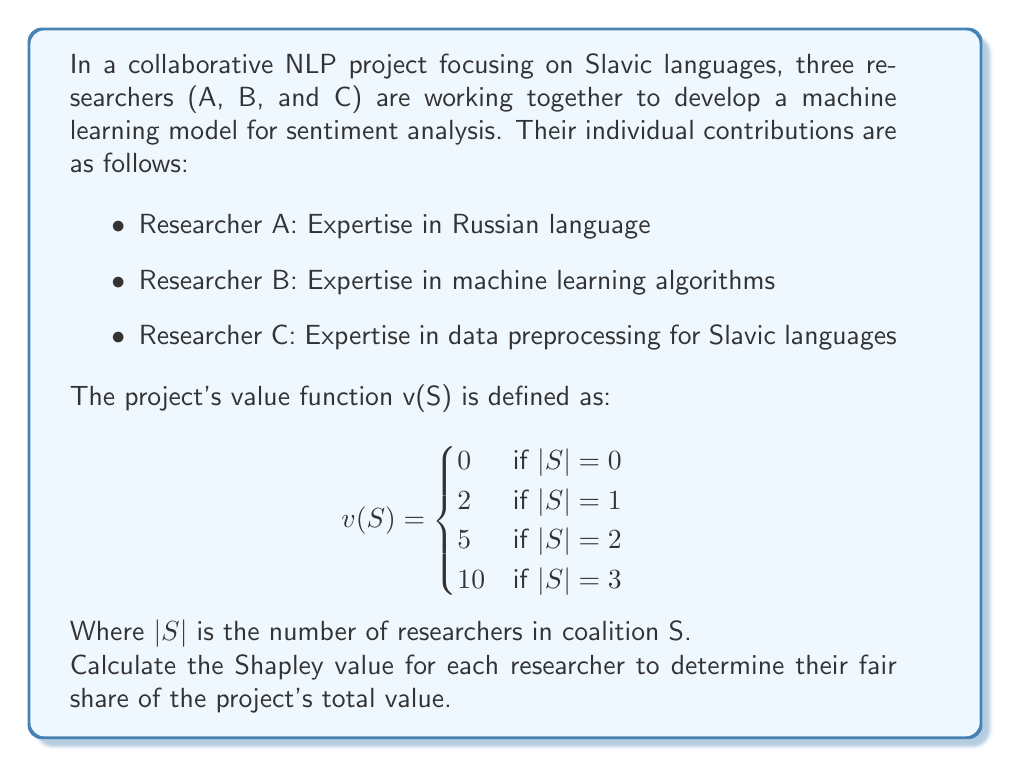Provide a solution to this math problem. To calculate the Shapley value for each researcher, we'll use the formula:

$$\phi_i(v) = \sum_{S \subseteq N \setminus \{i\}} \frac{|S|!(n-|S|-1)!}{n!}[v(S \cup \{i\}) - v(S)]$$

Where:
- $N$ is the set of all researchers
- $n$ is the total number of researchers (3 in this case)
- $S$ is a subset of researchers not including researcher $i$

Step 1: List all possible coalitions and their marginal contributions:

1. {} → {A}: 2 - 0 = 2
2. {} → {B}: 2 - 0 = 2
3. {} → {C}: 2 - 0 = 2
4. {A} → {A,B}: 5 - 2 = 3
5. {A} → {A,C}: 5 - 2 = 3
6. {B} → {A,B}: 5 - 2 = 3
7. {B} → {B,C}: 5 - 2 = 3
8. {C} → {A,C}: 5 - 2 = 3
9. {C} → {B,C}: 5 - 2 = 3
10. {A,B} → {A,B,C}: 10 - 5 = 5
11. {A,C} → {A,B,C}: 10 - 5 = 5
12. {B,C} → {A,B,C}: 10 - 5 = 5

Step 2: Calculate Shapley value for each researcher:

For Researcher A:
$$\phi_A(v) = \frac{1}{3}(2) + \frac{1}{6}(3) + \frac{1}{6}(3) + \frac{1}{3}(5) = \frac{10}{3}$$

For Researcher B:
$$\phi_B(v) = \frac{1}{3}(2) + \frac{1}{6}(3) + \frac{1}{6}(3) + \frac{1}{3}(5) = \frac{10}{3}$$

For Researcher C:
$$\phi_C(v) = \frac{1}{3}(2) + \frac{1}{6}(3) + \frac{1}{6}(3) + \frac{1}{3}(5) = \frac{10}{3}$$

Step 3: Verify that the sum of Shapley values equals the total project value:

$$\phi_A(v) + \phi_B(v) + \phi_C(v) = \frac{10}{3} + \frac{10}{3} + \frac{10}{3} = 10$$

This matches the total project value v(A,B,C) = 10.
Answer: Shapley values: A = $\frac{10}{3}$, B = $\frac{10}{3}$, C = $\frac{10}{3}$ 